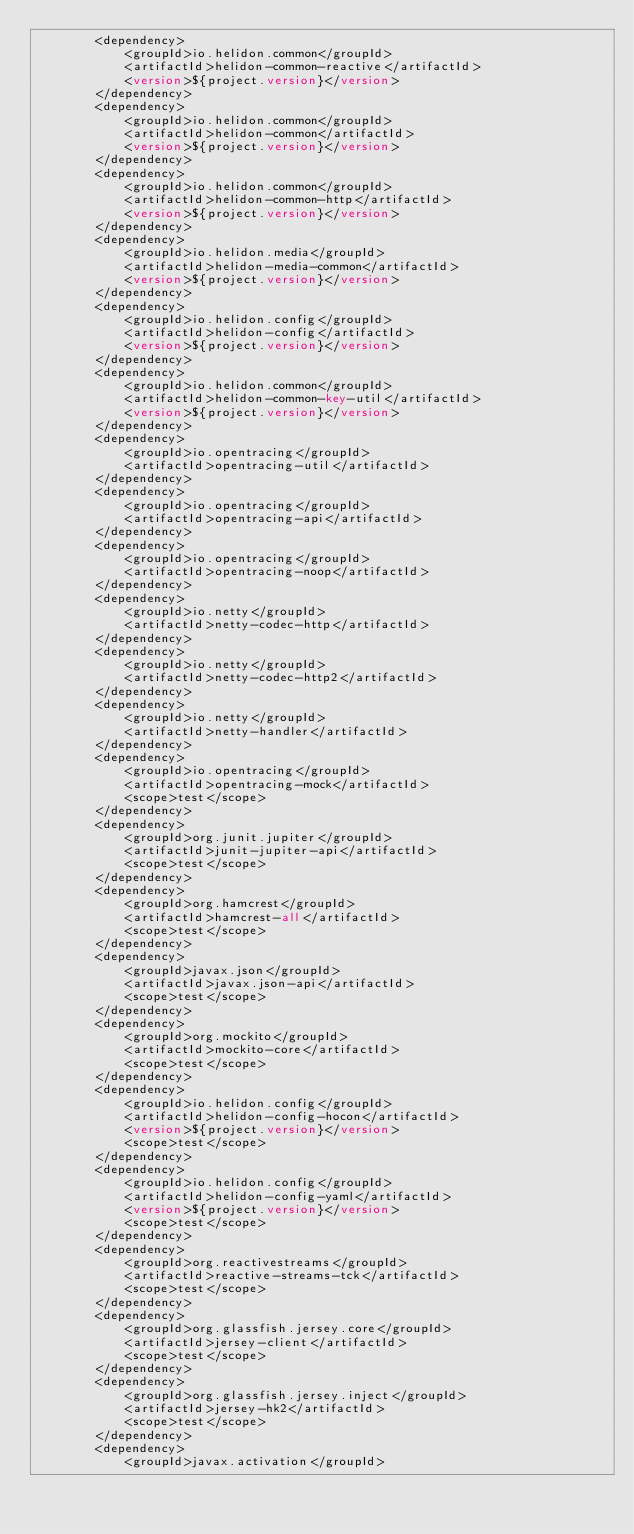Convert code to text. <code><loc_0><loc_0><loc_500><loc_500><_XML_>        <dependency>
            <groupId>io.helidon.common</groupId>
            <artifactId>helidon-common-reactive</artifactId>
            <version>${project.version}</version>
        </dependency>
        <dependency>
            <groupId>io.helidon.common</groupId>
            <artifactId>helidon-common</artifactId>
            <version>${project.version}</version>
        </dependency>
        <dependency>
            <groupId>io.helidon.common</groupId>
            <artifactId>helidon-common-http</artifactId>
            <version>${project.version}</version>
        </dependency>
        <dependency>
            <groupId>io.helidon.media</groupId>
            <artifactId>helidon-media-common</artifactId>
            <version>${project.version}</version>
        </dependency>
        <dependency>
            <groupId>io.helidon.config</groupId>
            <artifactId>helidon-config</artifactId>
            <version>${project.version}</version>
        </dependency>
        <dependency>
            <groupId>io.helidon.common</groupId>
            <artifactId>helidon-common-key-util</artifactId>
            <version>${project.version}</version>
        </dependency>
        <dependency>
            <groupId>io.opentracing</groupId>
            <artifactId>opentracing-util</artifactId>
        </dependency>
        <dependency>
            <groupId>io.opentracing</groupId>
            <artifactId>opentracing-api</artifactId>
        </dependency>
        <dependency>
            <groupId>io.opentracing</groupId>
            <artifactId>opentracing-noop</artifactId>
        </dependency>
        <dependency>
            <groupId>io.netty</groupId>
            <artifactId>netty-codec-http</artifactId>
        </dependency>
        <dependency>
            <groupId>io.netty</groupId>
            <artifactId>netty-codec-http2</artifactId>
        </dependency>
        <dependency>
            <groupId>io.netty</groupId>
            <artifactId>netty-handler</artifactId>
        </dependency>
        <dependency>
            <groupId>io.opentracing</groupId>
            <artifactId>opentracing-mock</artifactId>
            <scope>test</scope>
        </dependency>
        <dependency>
            <groupId>org.junit.jupiter</groupId>
            <artifactId>junit-jupiter-api</artifactId>
            <scope>test</scope>
        </dependency>
        <dependency>
            <groupId>org.hamcrest</groupId>
            <artifactId>hamcrest-all</artifactId>
            <scope>test</scope>
        </dependency>
        <dependency>
            <groupId>javax.json</groupId>
            <artifactId>javax.json-api</artifactId>
            <scope>test</scope>
        </dependency>
        <dependency>
            <groupId>org.mockito</groupId>
            <artifactId>mockito-core</artifactId>
            <scope>test</scope>
        </dependency>
        <dependency>
            <groupId>io.helidon.config</groupId>
            <artifactId>helidon-config-hocon</artifactId>
            <version>${project.version}</version>
            <scope>test</scope>
        </dependency>
        <dependency>
            <groupId>io.helidon.config</groupId>
            <artifactId>helidon-config-yaml</artifactId>
            <version>${project.version}</version>
            <scope>test</scope>
        </dependency>
        <dependency>
            <groupId>org.reactivestreams</groupId>
            <artifactId>reactive-streams-tck</artifactId>
            <scope>test</scope>
        </dependency>
        <dependency>
            <groupId>org.glassfish.jersey.core</groupId>
            <artifactId>jersey-client</artifactId>
            <scope>test</scope>
        </dependency>
        <dependency>
            <groupId>org.glassfish.jersey.inject</groupId>
            <artifactId>jersey-hk2</artifactId>
            <scope>test</scope>
        </dependency>
        <dependency>
            <groupId>javax.activation</groupId></code> 